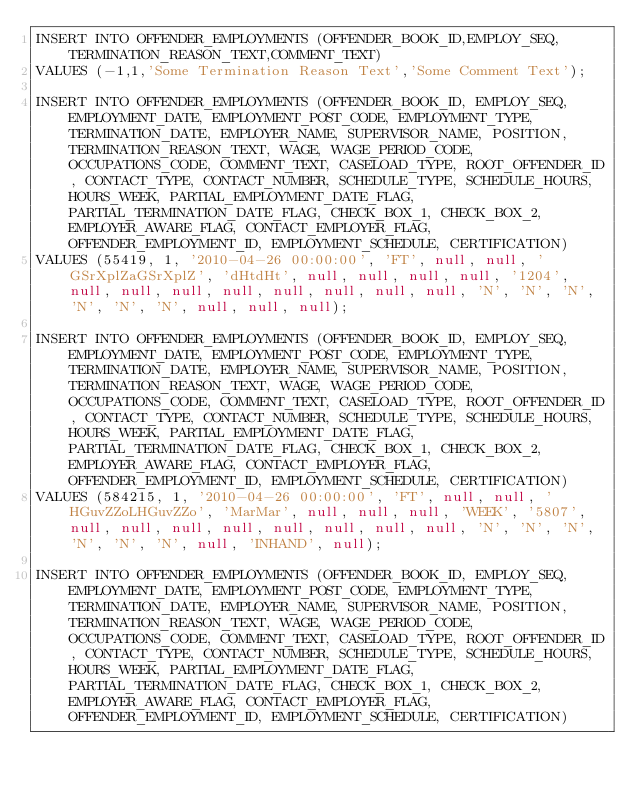<code> <loc_0><loc_0><loc_500><loc_500><_SQL_>INSERT INTO OFFENDER_EMPLOYMENTS (OFFENDER_BOOK_ID,EMPLOY_SEQ,TERMINATION_REASON_TEXT,COMMENT_TEXT)
VALUES (-1,1,'Some Termination Reason Text','Some Comment Text');

INSERT INTO OFFENDER_EMPLOYMENTS (OFFENDER_BOOK_ID, EMPLOY_SEQ, EMPLOYMENT_DATE, EMPLOYMENT_POST_CODE, EMPLOYMENT_TYPE, TERMINATION_DATE, EMPLOYER_NAME, SUPERVISOR_NAME, POSITION, TERMINATION_REASON_TEXT, WAGE, WAGE_PERIOD_CODE, OCCUPATIONS_CODE, COMMENT_TEXT, CASELOAD_TYPE, ROOT_OFFENDER_ID, CONTACT_TYPE, CONTACT_NUMBER, SCHEDULE_TYPE, SCHEDULE_HOURS, HOURS_WEEK, PARTIAL_EMPLOYMENT_DATE_FLAG, PARTIAL_TERMINATION_DATE_FLAG, CHECK_BOX_1, CHECK_BOX_2, EMPLOYER_AWARE_FLAG, CONTACT_EMPLOYER_FLAG, OFFENDER_EMPLOYMENT_ID, EMPLOYMENT_SCHEDULE, CERTIFICATION)
VALUES (55419, 1, '2010-04-26 00:00:00', 'FT', null, null, 'GSrXplZaGSrXplZ', 'dHtdHt', null, null, null, null, '1204', null, null, null, null, null, null, null, null, 'N', 'N', 'N', 'N', 'N', 'N', null, null, null);

INSERT INTO OFFENDER_EMPLOYMENTS (OFFENDER_BOOK_ID, EMPLOY_SEQ, EMPLOYMENT_DATE, EMPLOYMENT_POST_CODE, EMPLOYMENT_TYPE, TERMINATION_DATE, EMPLOYER_NAME, SUPERVISOR_NAME, POSITION, TERMINATION_REASON_TEXT, WAGE, WAGE_PERIOD_CODE, OCCUPATIONS_CODE, COMMENT_TEXT, CASELOAD_TYPE, ROOT_OFFENDER_ID, CONTACT_TYPE, CONTACT_NUMBER, SCHEDULE_TYPE, SCHEDULE_HOURS, HOURS_WEEK, PARTIAL_EMPLOYMENT_DATE_FLAG, PARTIAL_TERMINATION_DATE_FLAG, CHECK_BOX_1, CHECK_BOX_2, EMPLOYER_AWARE_FLAG, CONTACT_EMPLOYER_FLAG, OFFENDER_EMPLOYMENT_ID, EMPLOYMENT_SCHEDULE, CERTIFICATION)
VALUES (584215, 1, '2010-04-26 00:00:00', 'FT', null, null, 'HGuvZZoLHGuvZZo', 'MarMar', null, null, null, 'WEEK', '5807', null, null, null, null, null, null, null, null, 'N', 'N', 'N', 'N', 'N', 'N', null, 'INHAND', null);

INSERT INTO OFFENDER_EMPLOYMENTS (OFFENDER_BOOK_ID, EMPLOY_SEQ, EMPLOYMENT_DATE, EMPLOYMENT_POST_CODE, EMPLOYMENT_TYPE, TERMINATION_DATE, EMPLOYER_NAME, SUPERVISOR_NAME, POSITION, TERMINATION_REASON_TEXT, WAGE, WAGE_PERIOD_CODE, OCCUPATIONS_CODE, COMMENT_TEXT, CASELOAD_TYPE, ROOT_OFFENDER_ID, CONTACT_TYPE, CONTACT_NUMBER, SCHEDULE_TYPE, SCHEDULE_HOURS, HOURS_WEEK, PARTIAL_EMPLOYMENT_DATE_FLAG, PARTIAL_TERMINATION_DATE_FLAG, CHECK_BOX_1, CHECK_BOX_2, EMPLOYER_AWARE_FLAG, CONTACT_EMPLOYER_FLAG, OFFENDER_EMPLOYMENT_ID, EMPLOYMENT_SCHEDULE, CERTIFICATION)</code> 